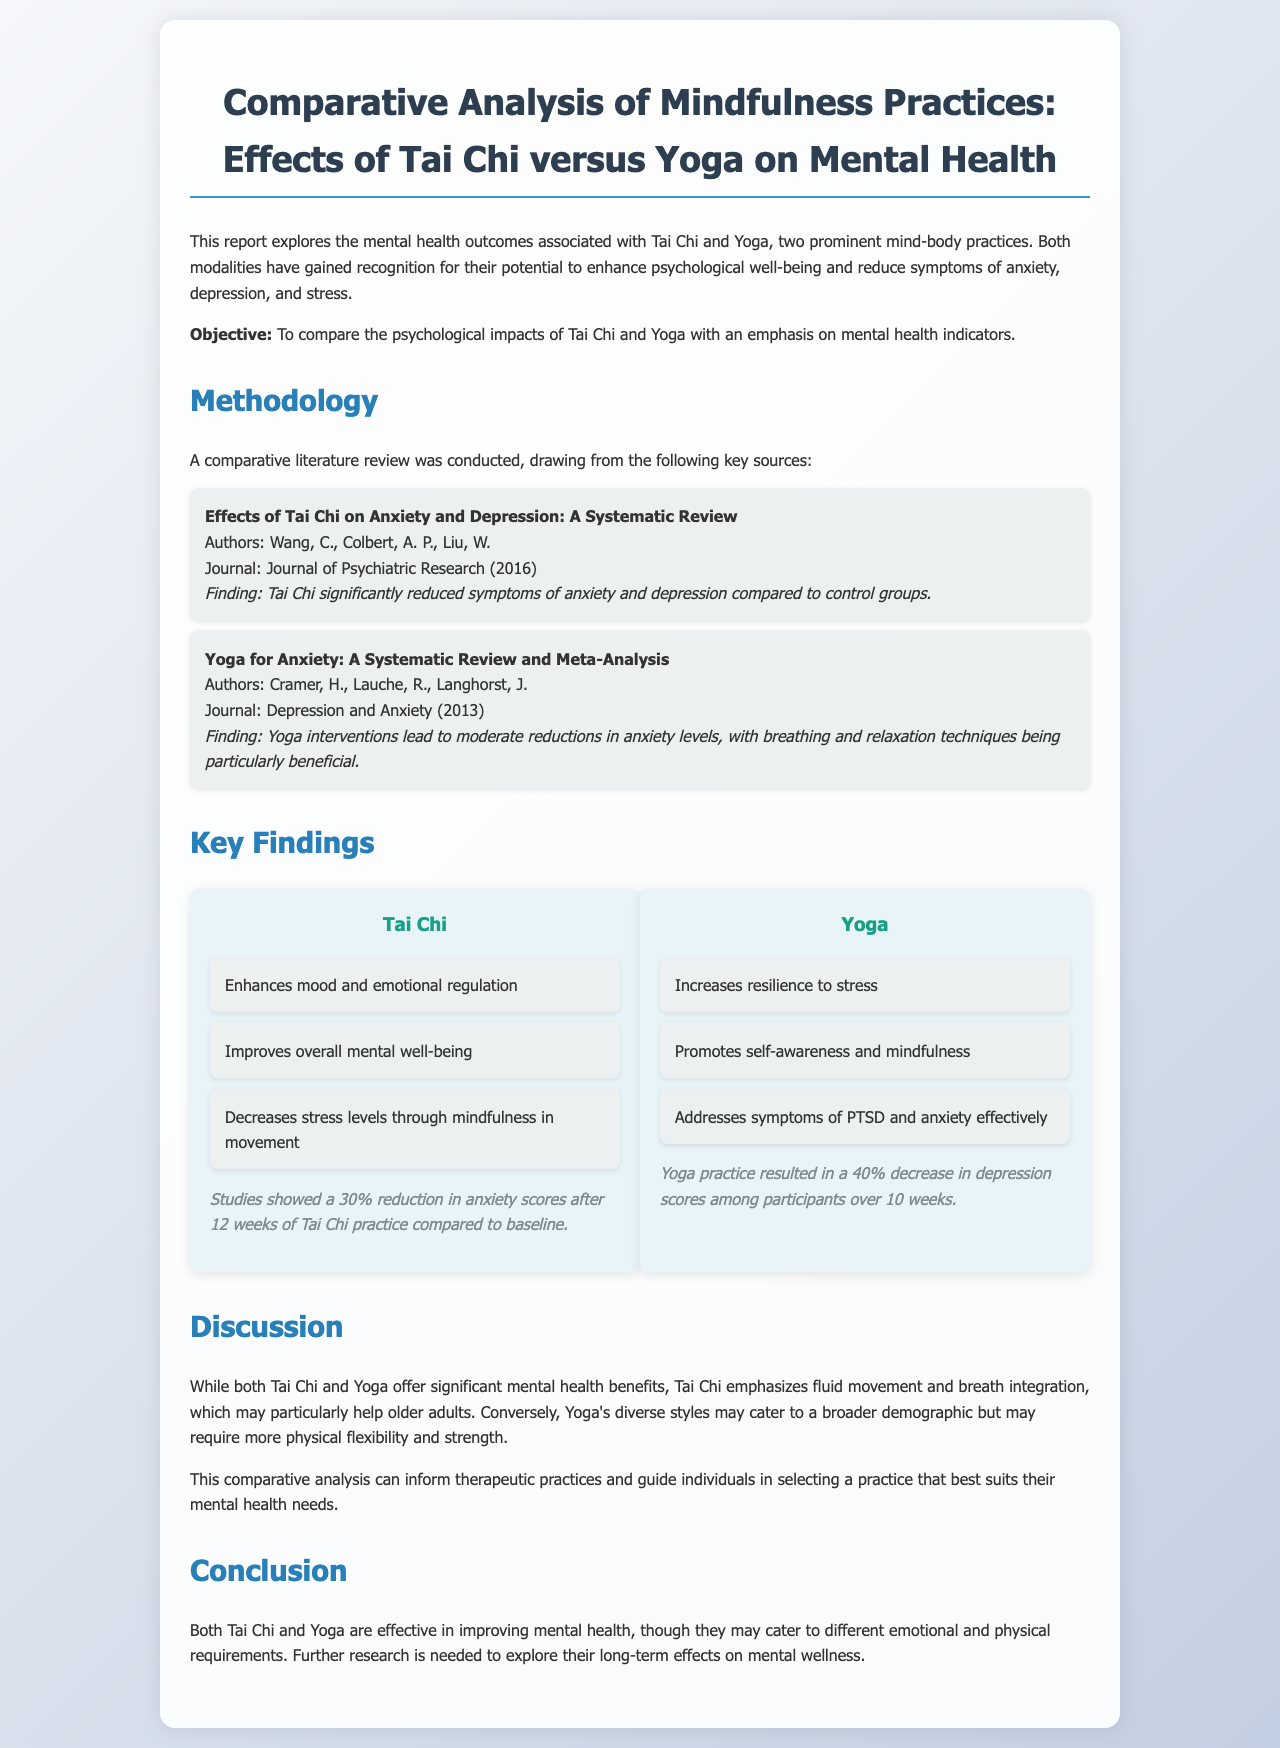what is the main objective of the report? The objective is stated in the introduction as comparing the psychological impacts of Tai Chi and Yoga with an emphasis on mental health indicators.
Answer: To compare the psychological impacts of Tai Chi and Yoga who conducted the systematic review on Tai Chi's effects? The systematic review is authored by Wang, C., Colbert, A. P., Liu, W. as mentioned in the methodology section.
Answer: Wang, C., Colbert, A. P., Liu, W what percentage reduction in anxiety scores was reported after 12 weeks of Tai Chi practice? The key findings section indicates a 30% reduction in anxiety scores after 12 weeks of practice.
Answer: 30% which practice showed a 40% decrease in depression scores over 10 weeks? The findings clearly state that Yoga practice resulted in a 40% decrease in depression scores among participants.
Answer: Yoga what is highlighted as a unique feature of Tai Chi in the discussion? The discussion mentions that Tai Chi emphasizes fluid movement and breath integration, which may particularly help older adults.
Answer: Fluid movement and breath integration what aspect of Yoga is indicated as beneficial for PTSD? The findings indicate that Yoga addresses symptoms of PTSD effectively, highlighting a specific benefit of the practice.
Answer: Addresses symptoms of PTSD which type of individuals may benefit more from Tai Chi as per the discussion? The discussion suggests that Tai Chi may particularly help older adults due to its emphasis on certain features.
Answer: Older adults what does the report conclude about the effectiveness of Tai Chi and Yoga? The conclusion states that both Tai Chi and Yoga are effective in improving mental health but may cater to different requirements.
Answer: Both are effective in improving mental health 